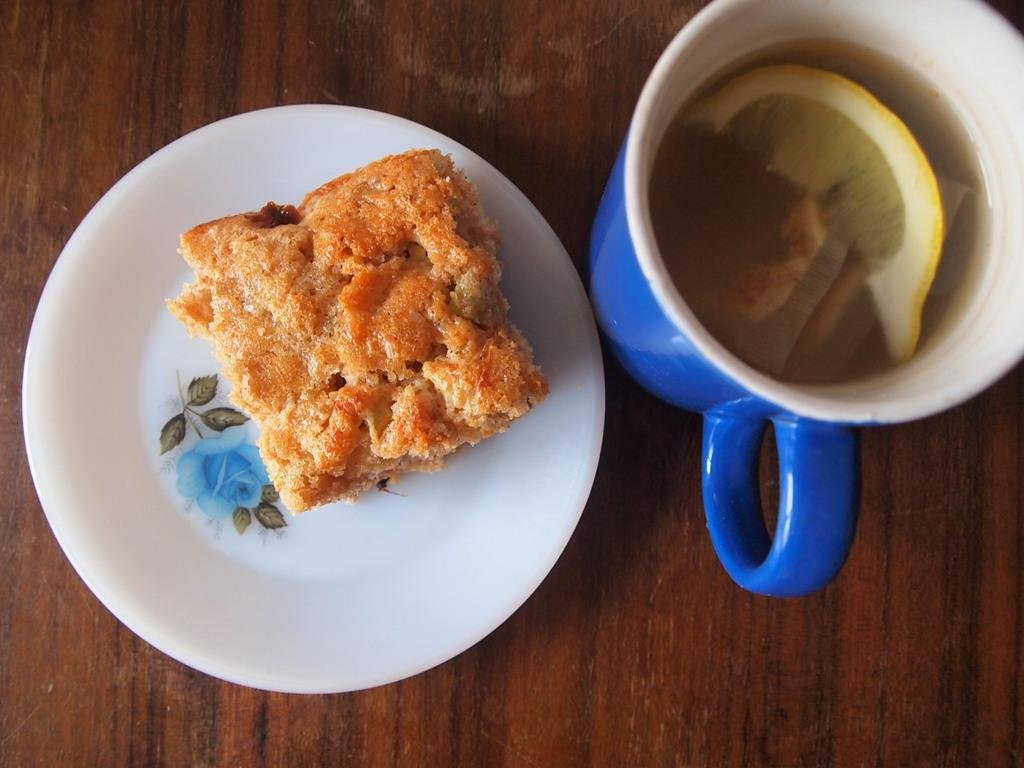What is on the plate in the image? There is a food item on a plate in the image. What else can be seen on the table besides the plate? There is a glass in the image. What is inside the glass? The glass contains liquid. Where is this scene taking place? The scene is taking place on a table. What type of guide is leading a tour in the image? There is no guide or tour present in the image. 